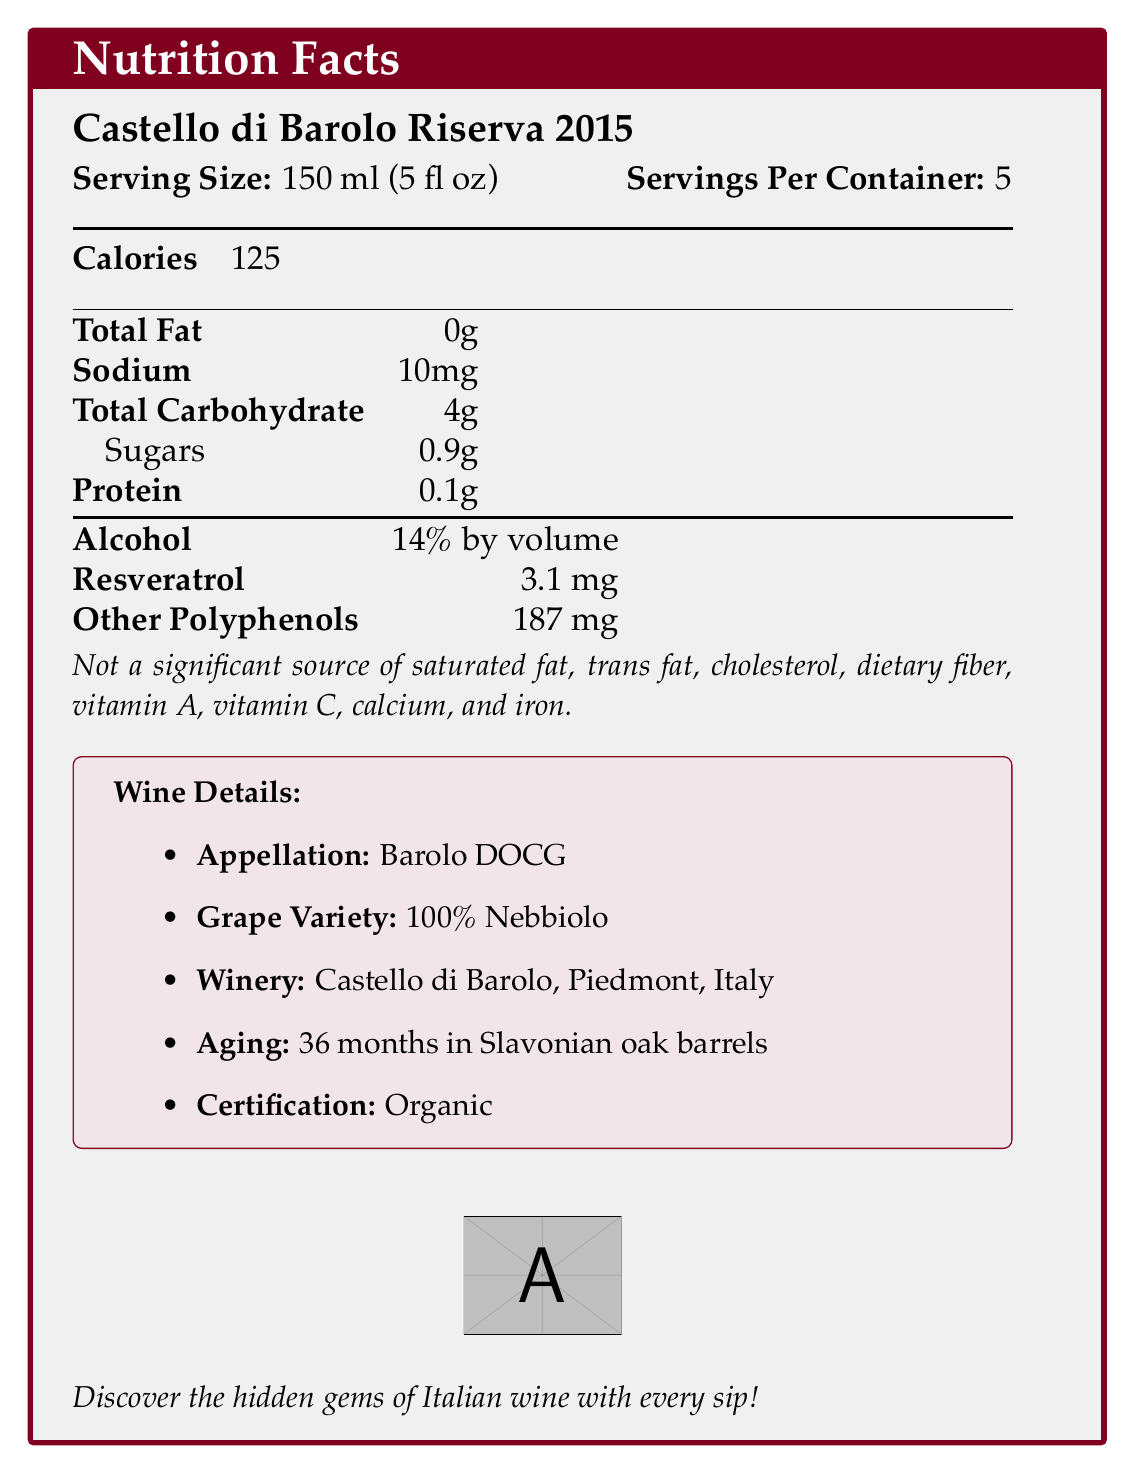who is the winemaker? The document states “Winemaker: Giulia Rossi” in the wine details section.
Answer: Giulia Rossi what is the resveratrol content per serving? The document provides “Resveratrol: 3.1 mg” in the nutrition facts section.
Answer: 3.1 mg what is the serving size for Castello di Barolo Riserva 2015? The serving size is listed as 150 ml (5 fl oz) in the document.
Answer: 150 ml (5 fl oz) what kind of grape variety is used in this wine? The document specifies that the wine is made from “100% Nebbiolo” in the wine details section.
Answer: 100% Nebbiolo how many servings are in one container? The document indicates “Servings Per Container: 5” in the nutrition facts section.
Answer: 5 what kind of certification does this wine have? The wine is labeled as “Organic” under the wine details section.
Answer: Organic what is the alcohol content by volume? The document lists the alcohol content as “14% by volume” in the nutrition facts section.
Answer: 14% what is the total carbohydrate content in this wine? A. 2g B. 3g C. 4g D. 5g The document shows that the “Total Carbohydrate” content is “4g”.
Answer: C how many calories are there per serving? A. 100 B. 110 C. 120 D. 125 The document states that each serving contains “125” calories.
Answer: D is this wine suitable for someone looking for zero sodium content? The document states that there are “10mg” of sodium per serving.
Answer: No can this wine be consumed beyond 20 years of cellaring? The document mentions a cellaring potential of “20-30 years”.
Answer: Yes summarize the main idea of the document. The document includes specific nutrition information, such as calorie content, carbohydrates, and resveratrol levels, as well as detailed wine characteristics, including grape variety, winery, aging process, certification, and more.
Answer: The document provides detailed nutrition facts and wine details for Castello di Barolo Riserva 2015, a boutique Piedmontese Barolo. what is the altitude range of the vineyard? The document specifies the “vineyard altitude” as being between “300-400 meters above sea level”.
Answer: 300-400 meters above sea level what kind of soil type does this vineyard have? The document states the soil type as “Calcareous clay with marine sediments”.
Answer: Calcareous clay with marine sediments how long does the aging process take for this wine? The wine is aged for “36 months in Slavonian oak barrels” as noted in the wine details section.
Answer: 36 months when was the bottling date? The document mentions the “bottling date” as “July 2019”.
Answer: July 2019 when was the harvest date for this vintage? The harvest date is listed as “October 10-15, 2015” in the document.
Answer: October 10-15, 2015 what temperature should this wine be served at? The document suggests a serving temperature of “18-20°C (64-68°F)”.
Answer: 18-20°C (64-68°F) what awards has this wine won? The document mentions that the wine received “97 points - Wine Spectator, 2020”.
Answer: 97 points - Wine Spectator, 2020 what are the tasting notes for Castello di Barolo Riserva 2015? The document provides tasting notes describing the wine as having “Rich aromas of dried roses, tar, and ripe cherries with hints of leather and tobacco”.
Answer: Rich aromas of dried roses, tar, and ripe cherries with hints of leather and tobacco what kind of closure type is used for this wine? The document states that the closure type is “Natural cork”.
Answer: Natural cork what is the production volume of this wine? The document mentions that it is a “Limited edition of 3,000 bottles”.
Answer: Limited edition of 3,000 bottles what kind of fermentation method is used for this wine? The document specifies the fermentation process as “30 days in stainless steel tanks with indigenous yeasts”.
Answer: 30 days in stainless steel tanks with indigenous yeasts who is the current owner of Castello di Barolo winery? The document does not provide information about the current owner of the winery.
Answer: Cannot be determined 